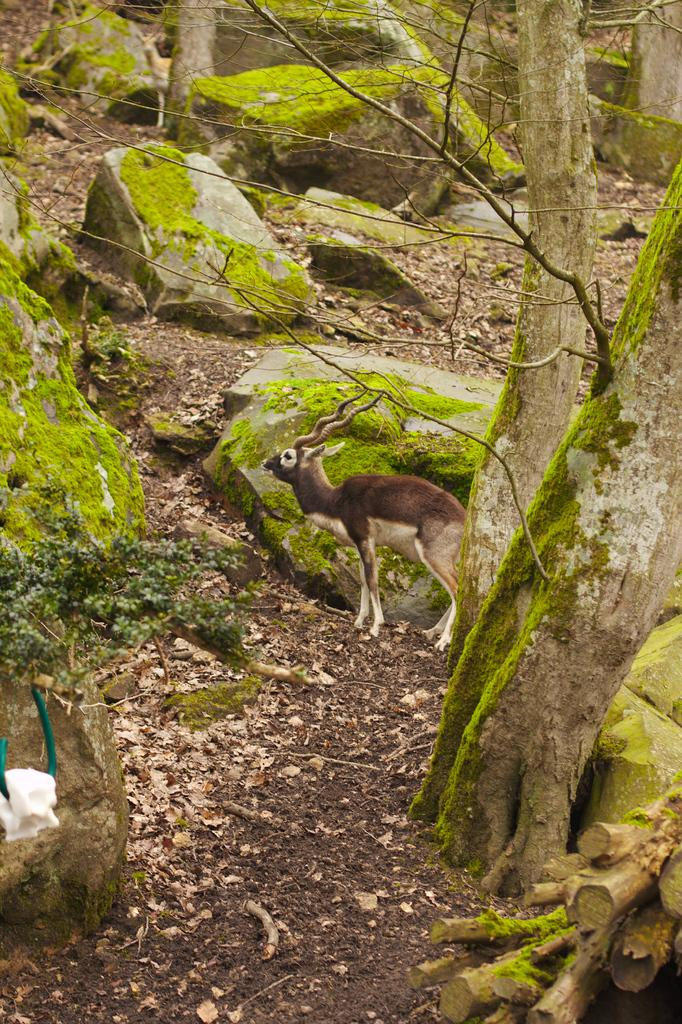What type of animal is present in the image? There is a deer in the image. What natural features can be seen in the image? There are rocks, trees, and plants in the image. What is on the ground in the image? There are leaves on the ground in the image. What day is it in the image? The provided facts do not mention the day, so it cannot be determined from the image. 